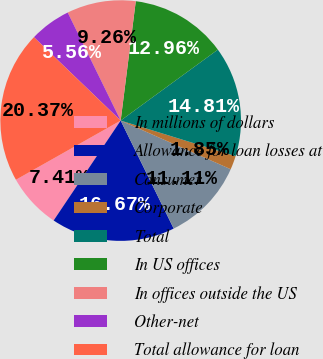<chart> <loc_0><loc_0><loc_500><loc_500><pie_chart><fcel>In millions of dollars<fcel>Allowance for loan losses at<fcel>Consumer<fcel>Corporate<fcel>Total<fcel>In US offices<fcel>In offices outside the US<fcel>Other-net<fcel>Total allowance for loan<nl><fcel>7.41%<fcel>16.67%<fcel>11.11%<fcel>1.85%<fcel>14.81%<fcel>12.96%<fcel>9.26%<fcel>5.56%<fcel>20.37%<nl></chart> 